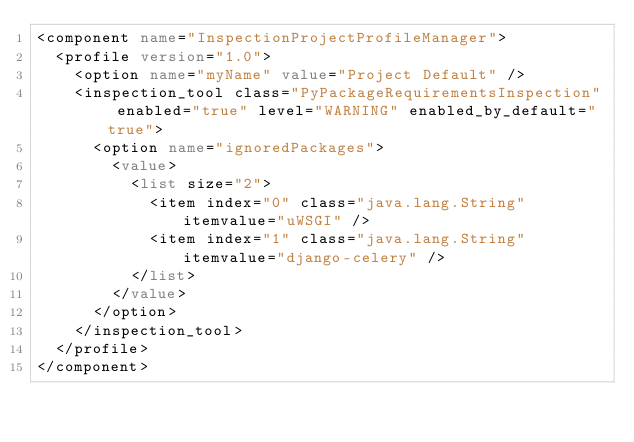<code> <loc_0><loc_0><loc_500><loc_500><_XML_><component name="InspectionProjectProfileManager">
  <profile version="1.0">
    <option name="myName" value="Project Default" />
    <inspection_tool class="PyPackageRequirementsInspection" enabled="true" level="WARNING" enabled_by_default="true">
      <option name="ignoredPackages">
        <value>
          <list size="2">
            <item index="0" class="java.lang.String" itemvalue="uWSGI" />
            <item index="1" class="java.lang.String" itemvalue="django-celery" />
          </list>
        </value>
      </option>
    </inspection_tool>
  </profile>
</component></code> 